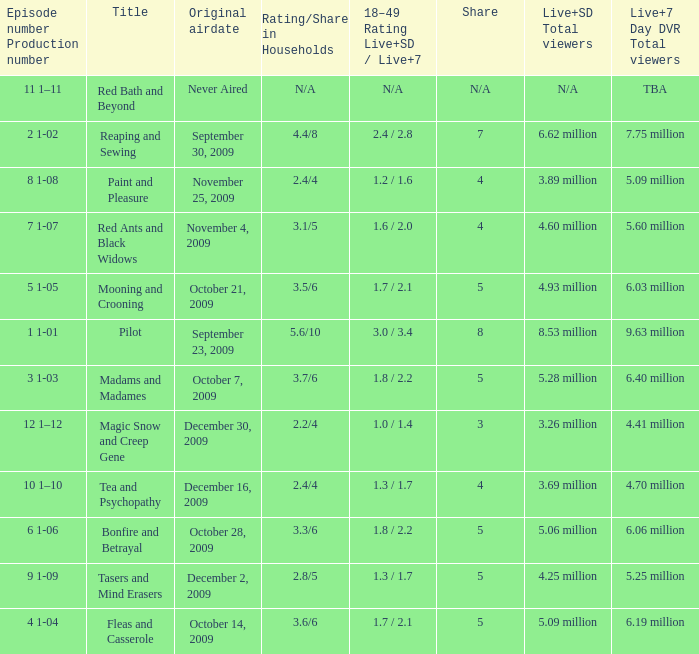When did the episode that had 3.69 million total viewers (Live and SD types combined) first air? December 16, 2009. 